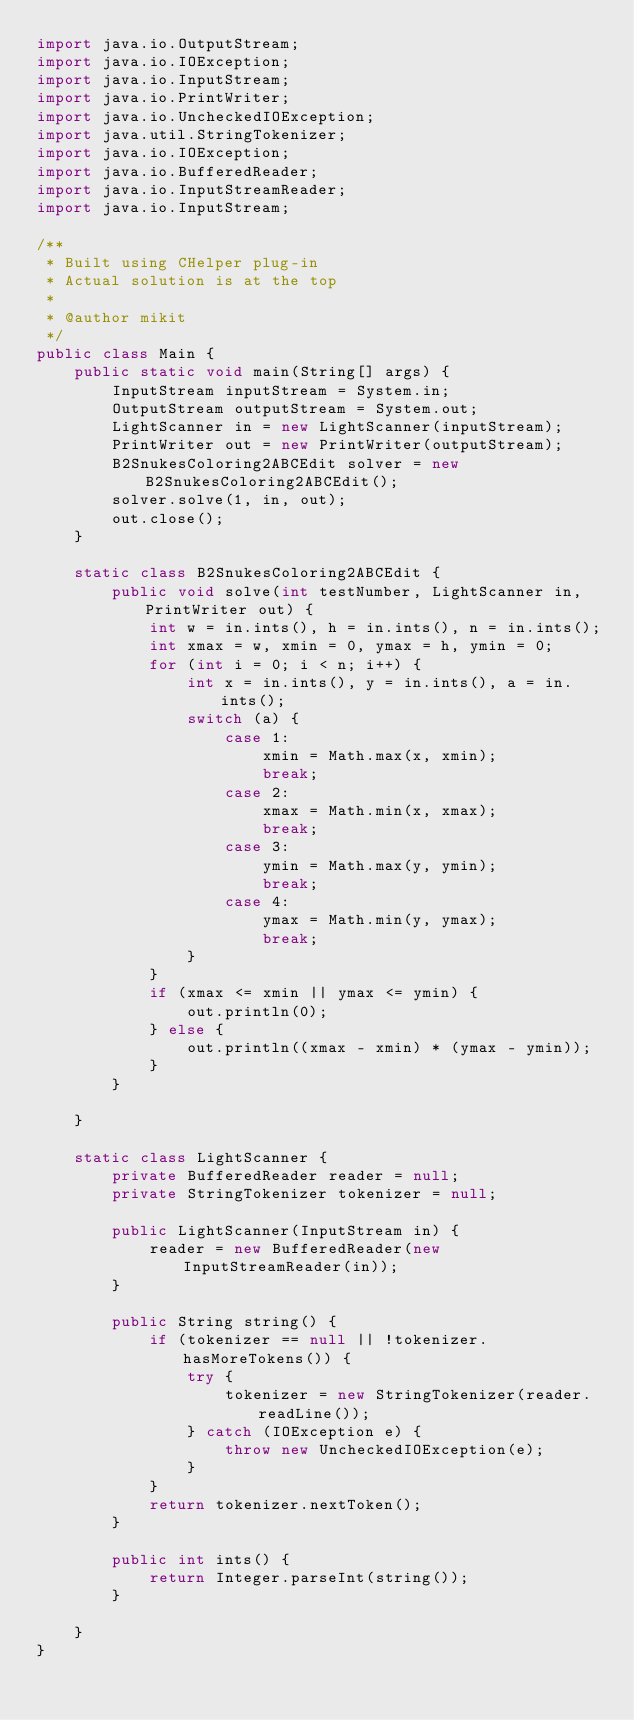Convert code to text. <code><loc_0><loc_0><loc_500><loc_500><_Java_>import java.io.OutputStream;
import java.io.IOException;
import java.io.InputStream;
import java.io.PrintWriter;
import java.io.UncheckedIOException;
import java.util.StringTokenizer;
import java.io.IOException;
import java.io.BufferedReader;
import java.io.InputStreamReader;
import java.io.InputStream;

/**
 * Built using CHelper plug-in
 * Actual solution is at the top
 *
 * @author mikit
 */
public class Main {
    public static void main(String[] args) {
        InputStream inputStream = System.in;
        OutputStream outputStream = System.out;
        LightScanner in = new LightScanner(inputStream);
        PrintWriter out = new PrintWriter(outputStream);
        B2SnukesColoring2ABCEdit solver = new B2SnukesColoring2ABCEdit();
        solver.solve(1, in, out);
        out.close();
    }

    static class B2SnukesColoring2ABCEdit {
        public void solve(int testNumber, LightScanner in, PrintWriter out) {
            int w = in.ints(), h = in.ints(), n = in.ints();
            int xmax = w, xmin = 0, ymax = h, ymin = 0;
            for (int i = 0; i < n; i++) {
                int x = in.ints(), y = in.ints(), a = in.ints();
                switch (a) {
                    case 1:
                        xmin = Math.max(x, xmin);
                        break;
                    case 2:
                        xmax = Math.min(x, xmax);
                        break;
                    case 3:
                        ymin = Math.max(y, ymin);
                        break;
                    case 4:
                        ymax = Math.min(y, ymax);
                        break;
                }
            }
            if (xmax <= xmin || ymax <= ymin) {
                out.println(0);
            } else {
                out.println((xmax - xmin) * (ymax - ymin));
            }
        }

    }

    static class LightScanner {
        private BufferedReader reader = null;
        private StringTokenizer tokenizer = null;

        public LightScanner(InputStream in) {
            reader = new BufferedReader(new InputStreamReader(in));
        }

        public String string() {
            if (tokenizer == null || !tokenizer.hasMoreTokens()) {
                try {
                    tokenizer = new StringTokenizer(reader.readLine());
                } catch (IOException e) {
                    throw new UncheckedIOException(e);
                }
            }
            return tokenizer.nextToken();
        }

        public int ints() {
            return Integer.parseInt(string());
        }

    }
}

</code> 